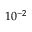Convert formula to latex. <formula><loc_0><loc_0><loc_500><loc_500>1 0 ^ { - 2 }</formula> 